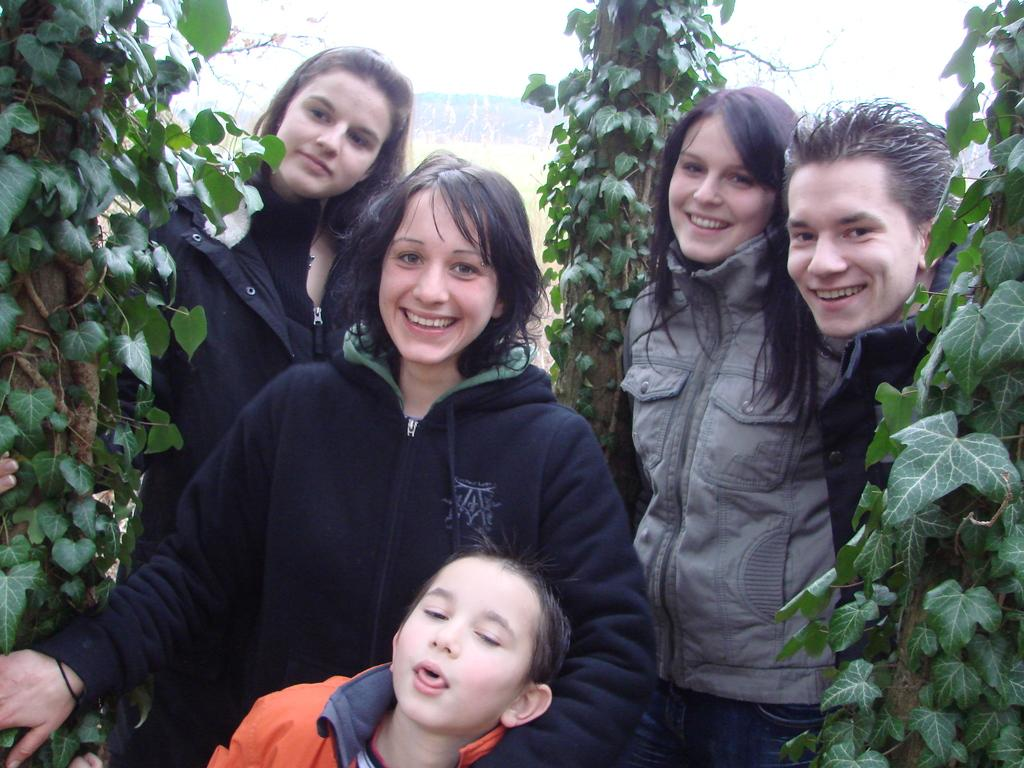Who or what can be seen in the image? There are people in the image. What can be seen in the distance behind the people? There are trees in the background of the image. What direction is the kite flying in the image? There is no kite present in the image, so it cannot be determined in which direction a kite might be flying. 